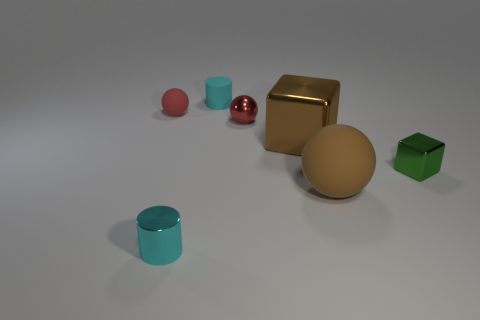How many cyan cylinders must be subtracted to get 1 cyan cylinders? 1 Subtract all large rubber balls. How many balls are left? 2 Subtract all cyan cubes. How many red spheres are left? 2 Add 2 large blue metal spheres. How many objects exist? 9 Subtract all cylinders. How many objects are left? 5 Subtract all gray spheres. Subtract all brown cylinders. How many spheres are left? 3 Subtract all large green rubber objects. Subtract all tiny shiny cubes. How many objects are left? 6 Add 5 small matte objects. How many small matte objects are left? 7 Add 5 blue things. How many blue things exist? 5 Subtract 0 blue balls. How many objects are left? 7 